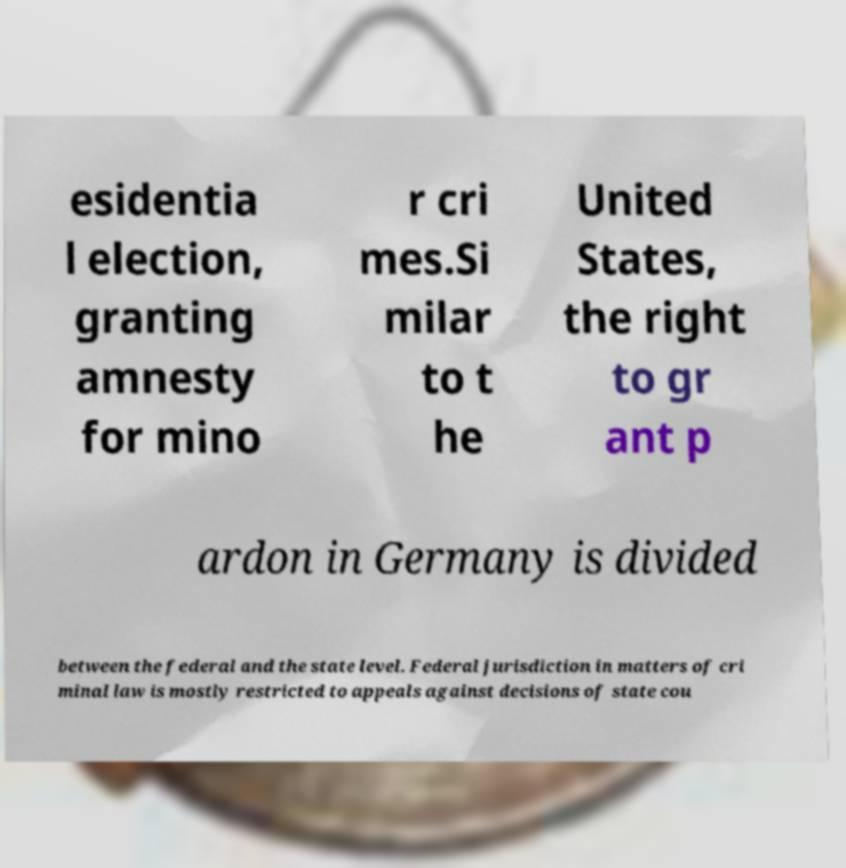I need the written content from this picture converted into text. Can you do that? esidentia l election, granting amnesty for mino r cri mes.Si milar to t he United States, the right to gr ant p ardon in Germany is divided between the federal and the state level. Federal jurisdiction in matters of cri minal law is mostly restricted to appeals against decisions of state cou 